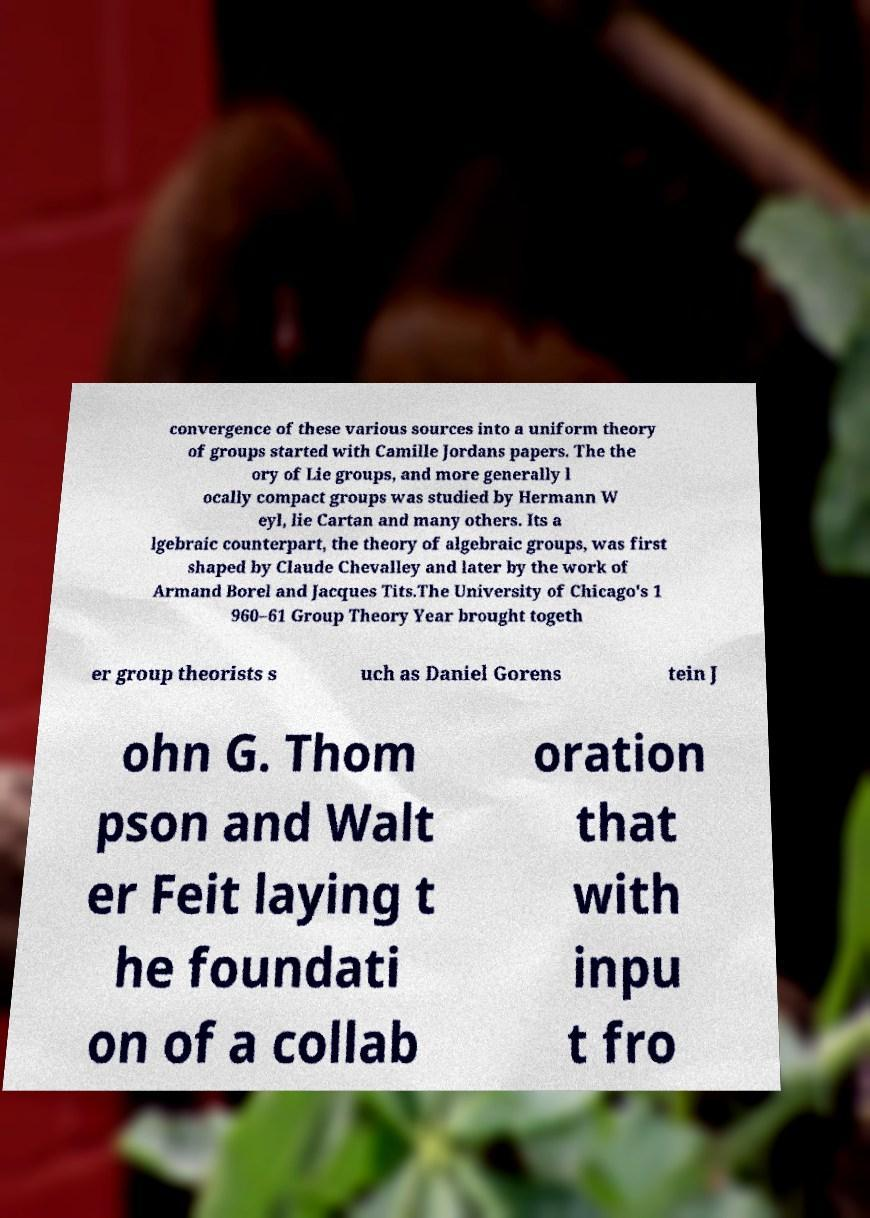Could you extract and type out the text from this image? convergence of these various sources into a uniform theory of groups started with Camille Jordans papers. The the ory of Lie groups, and more generally l ocally compact groups was studied by Hermann W eyl, lie Cartan and many others. Its a lgebraic counterpart, the theory of algebraic groups, was first shaped by Claude Chevalley and later by the work of Armand Borel and Jacques Tits.The University of Chicago's 1 960–61 Group Theory Year brought togeth er group theorists s uch as Daniel Gorens tein J ohn G. Thom pson and Walt er Feit laying t he foundati on of a collab oration that with inpu t fro 